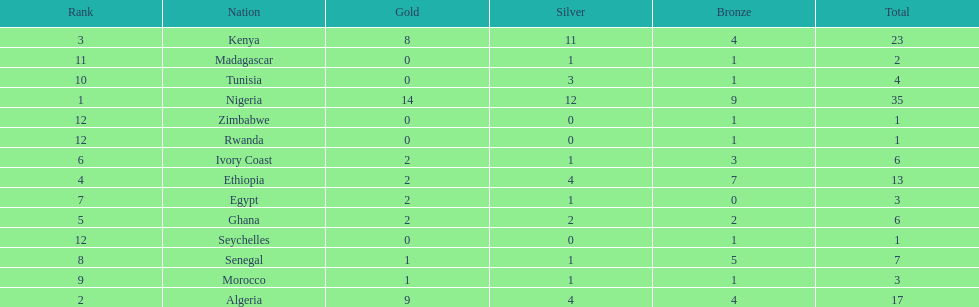What is the name of the first nation on this chart? Nigeria. 